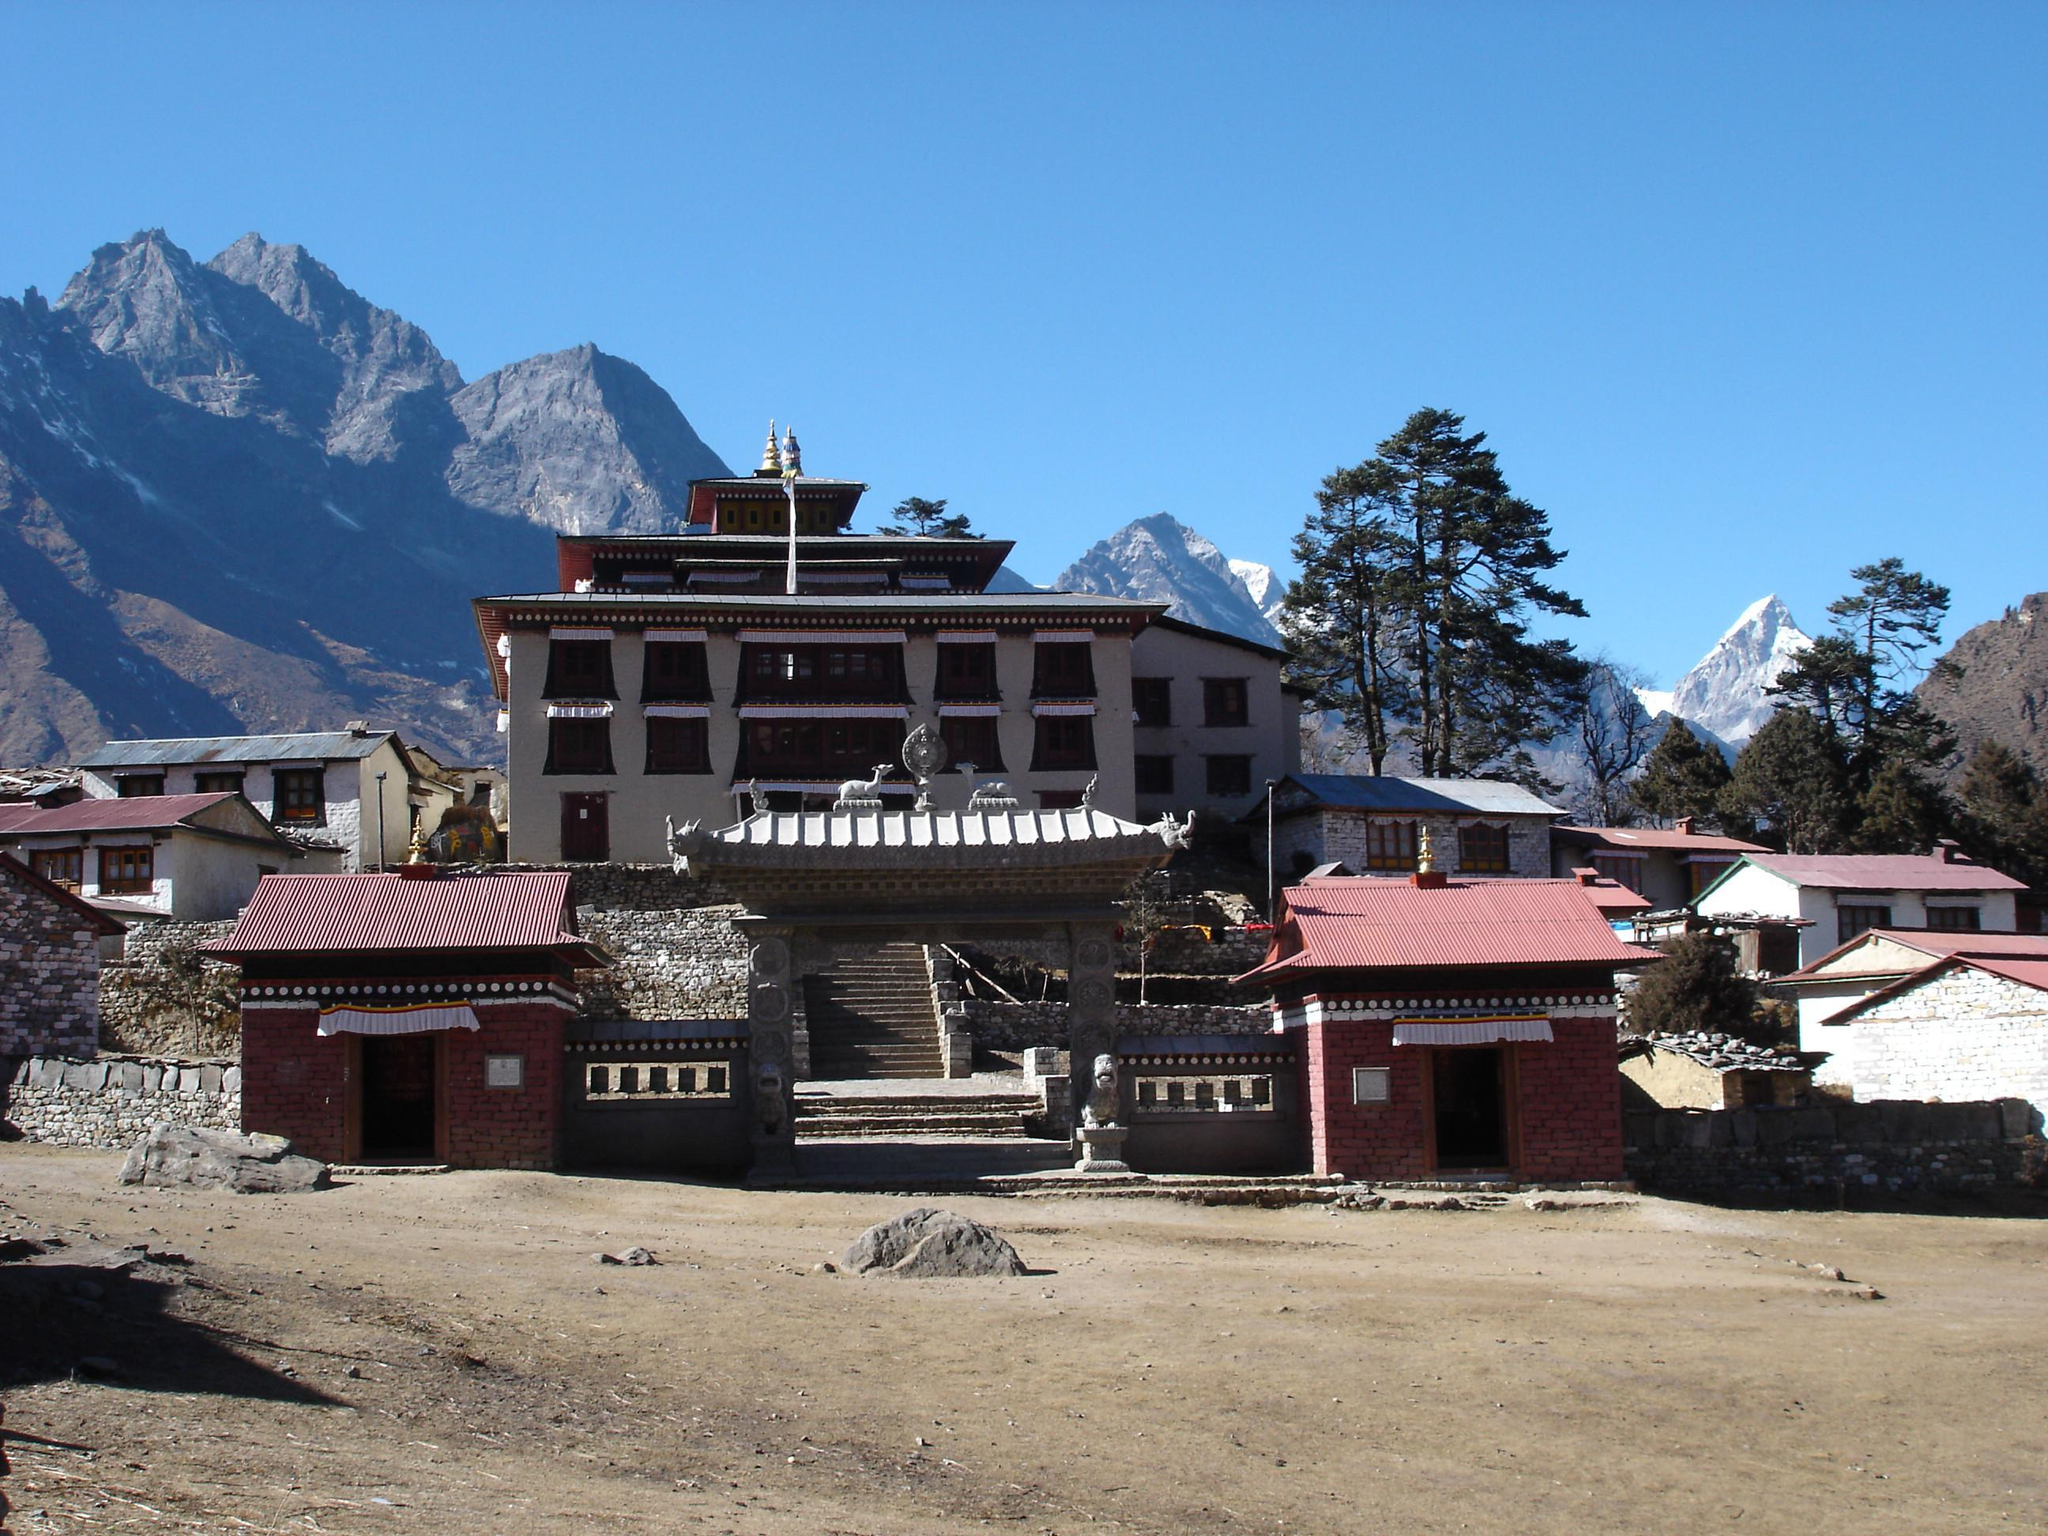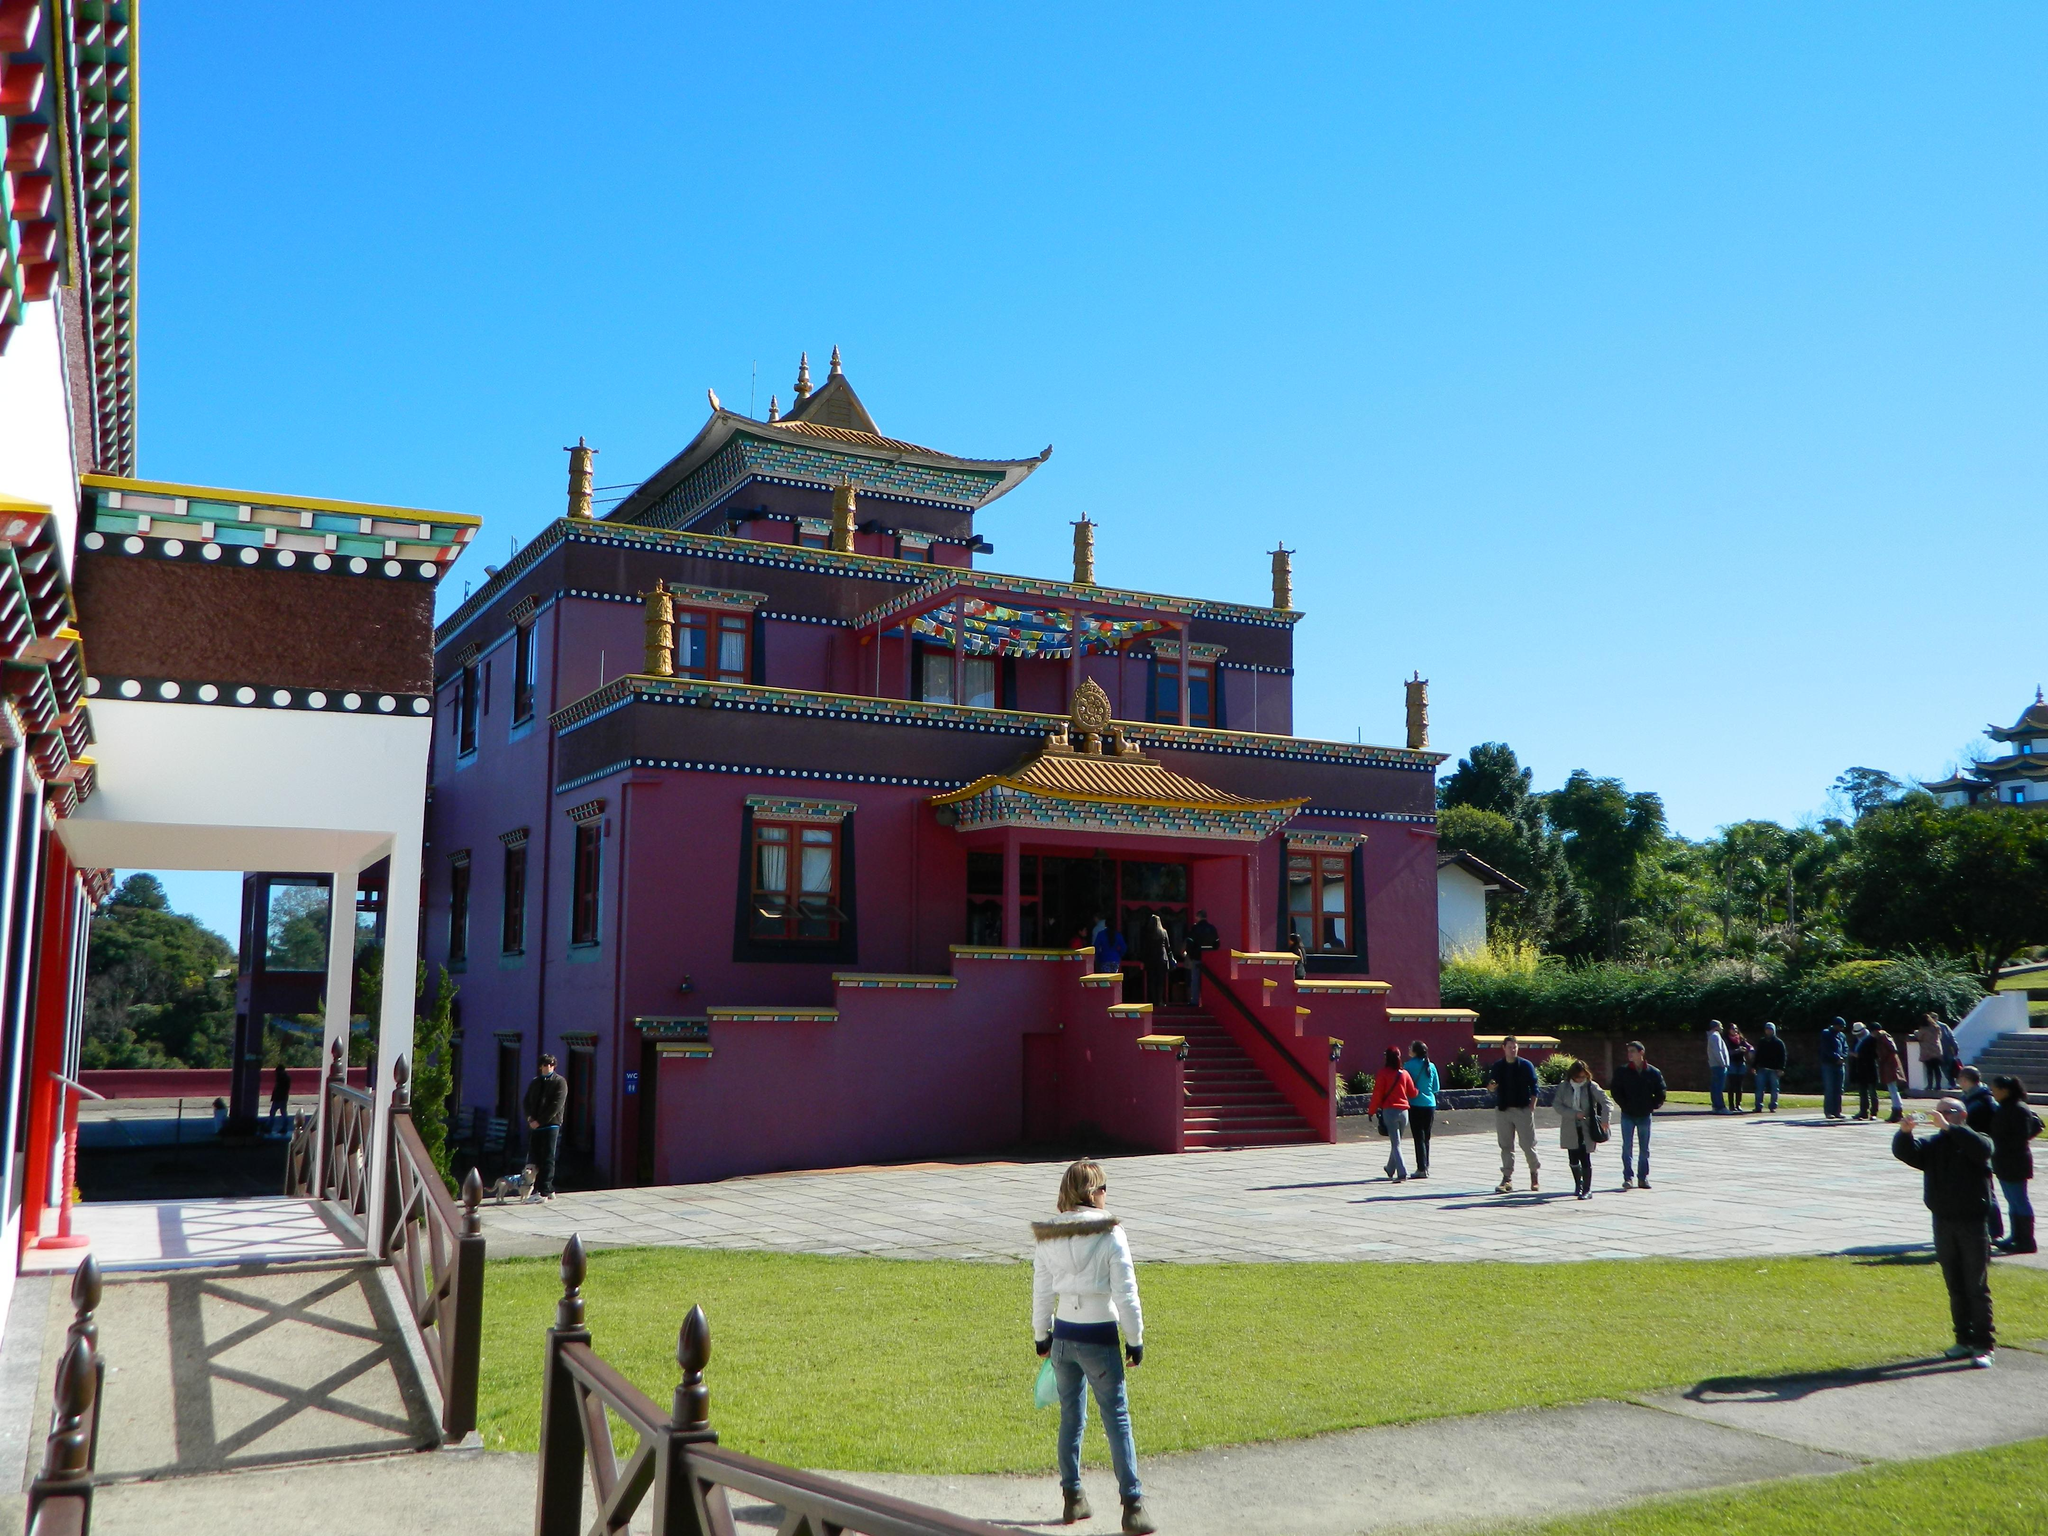The first image is the image on the left, the second image is the image on the right. Evaluate the accuracy of this statement regarding the images: "People are standing outside of the building in the image on the right.". Is it true? Answer yes or no. Yes. The first image is the image on the left, the second image is the image on the right. Assess this claim about the two images: "In the right image, a neutral colored building with at least eight windows on its front is on a hillside with mountains in the background.". Correct or not? Answer yes or no. No. 